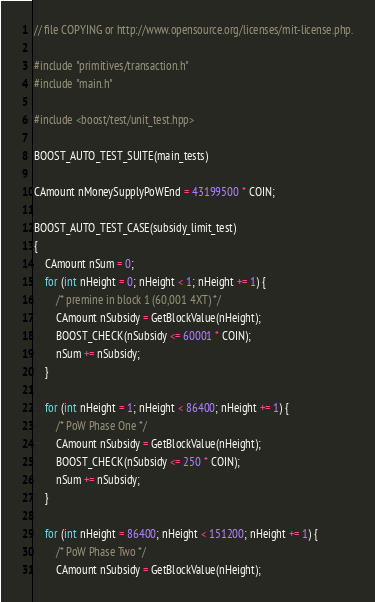Convert code to text. <code><loc_0><loc_0><loc_500><loc_500><_C++_>// file COPYING or http://www.opensource.org/licenses/mit-license.php.

#include "primitives/transaction.h"
#include "main.h"

#include <boost/test/unit_test.hpp>

BOOST_AUTO_TEST_SUITE(main_tests)

CAmount nMoneySupplyPoWEnd = 43199500 * COIN;

BOOST_AUTO_TEST_CASE(subsidy_limit_test)
{
    CAmount nSum = 0;
    for (int nHeight = 0; nHeight < 1; nHeight += 1) {
        /* premine in block 1 (60,001 4XT) */
        CAmount nSubsidy = GetBlockValue(nHeight);
        BOOST_CHECK(nSubsidy <= 60001 * COIN);
        nSum += nSubsidy;
    }

    for (int nHeight = 1; nHeight < 86400; nHeight += 1) {
        /* PoW Phase One */
        CAmount nSubsidy = GetBlockValue(nHeight);
        BOOST_CHECK(nSubsidy <= 250 * COIN);
        nSum += nSubsidy;
    }

    for (int nHeight = 86400; nHeight < 151200; nHeight += 1) {
        /* PoW Phase Two */
        CAmount nSubsidy = GetBlockValue(nHeight);</code> 